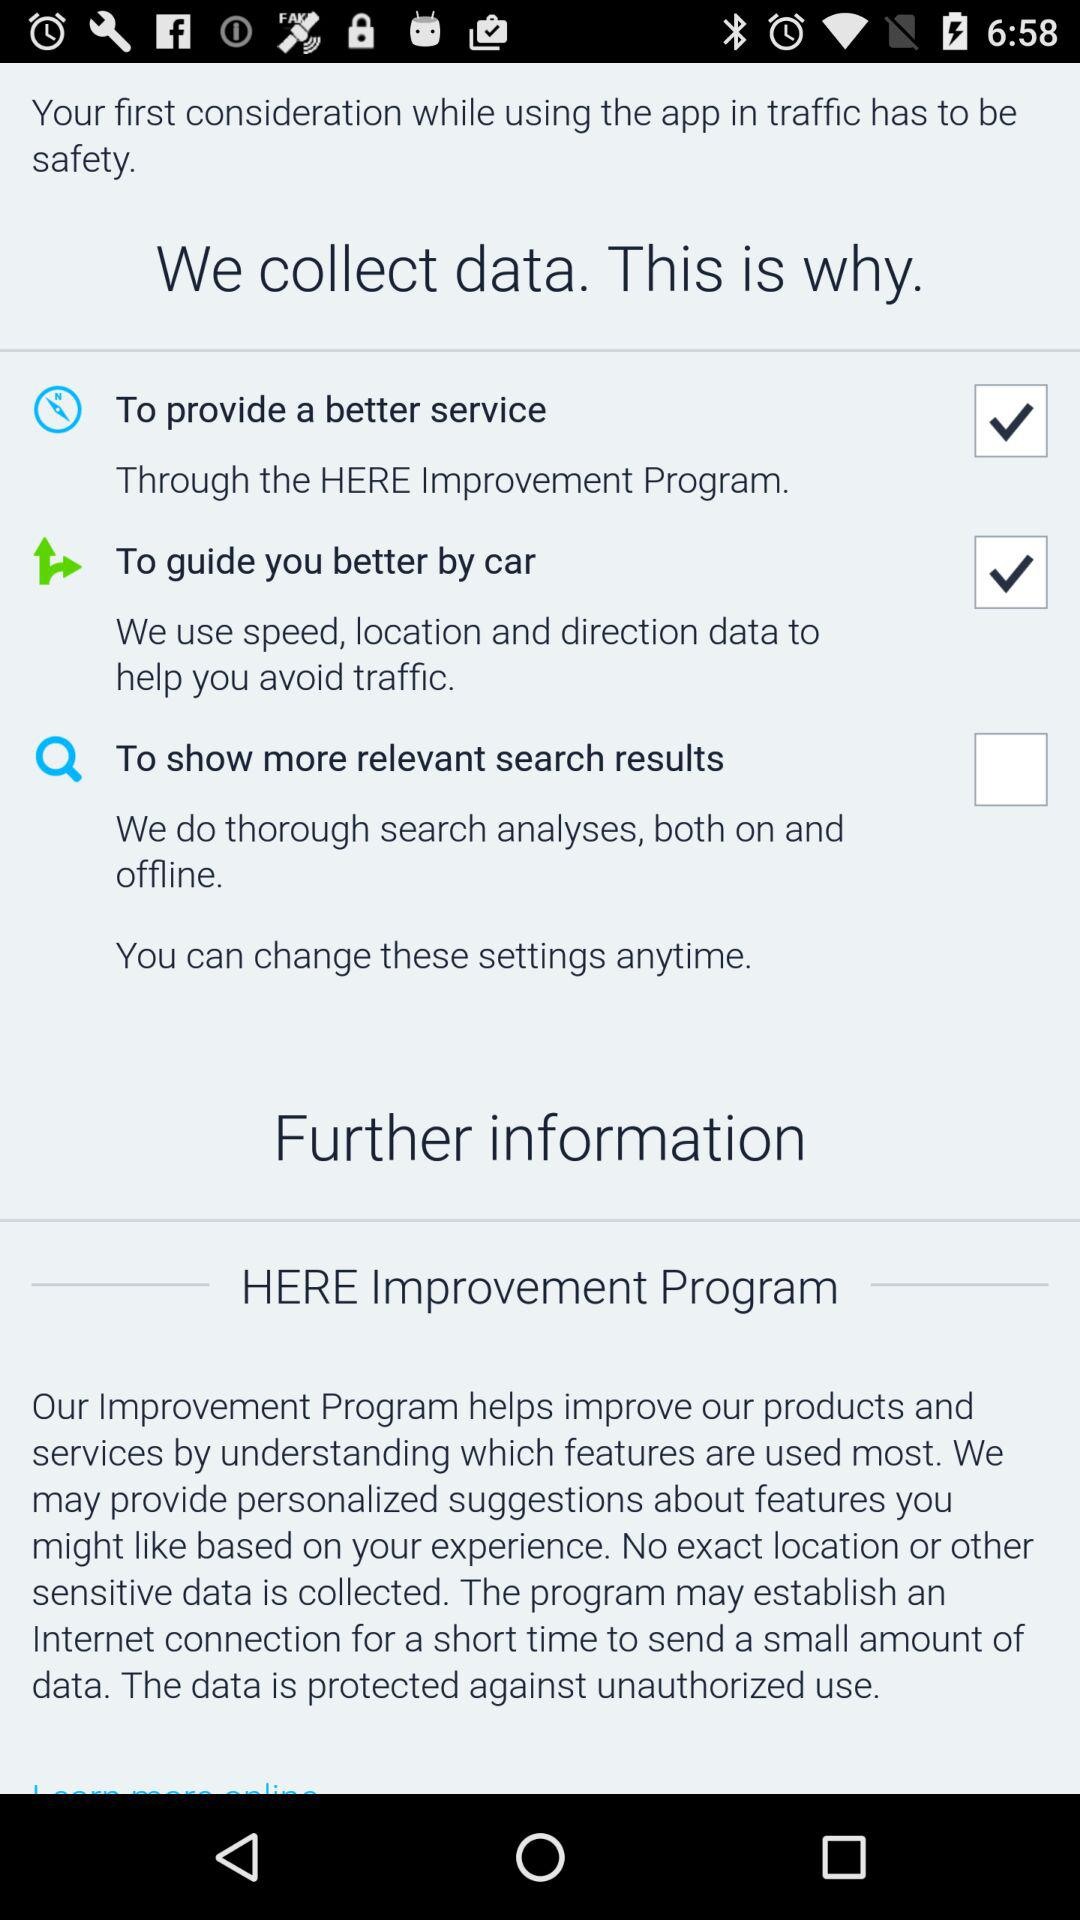Which options are marked as checked? The options marked as checked are : "To provide a better service" and "To guide you better by car". 